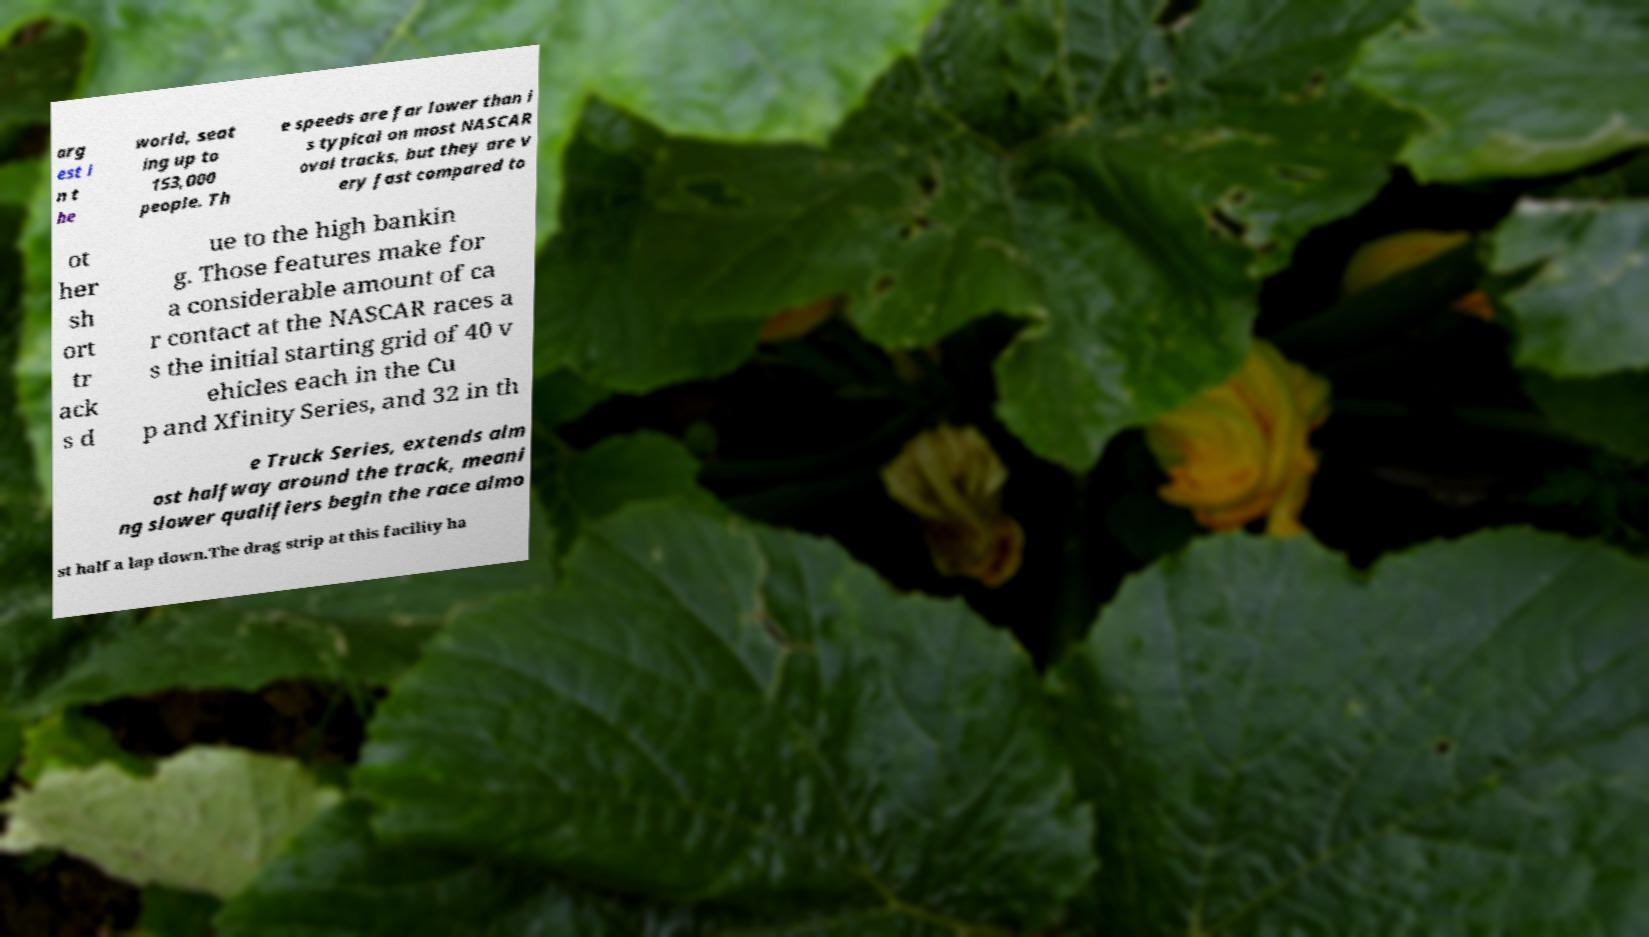Could you extract and type out the text from this image? arg est i n t he world, seat ing up to 153,000 people. Th e speeds are far lower than i s typical on most NASCAR oval tracks, but they are v ery fast compared to ot her sh ort tr ack s d ue to the high bankin g. Those features make for a considerable amount of ca r contact at the NASCAR races a s the initial starting grid of 40 v ehicles each in the Cu p and Xfinity Series, and 32 in th e Truck Series, extends alm ost halfway around the track, meani ng slower qualifiers begin the race almo st half a lap down.The drag strip at this facility ha 